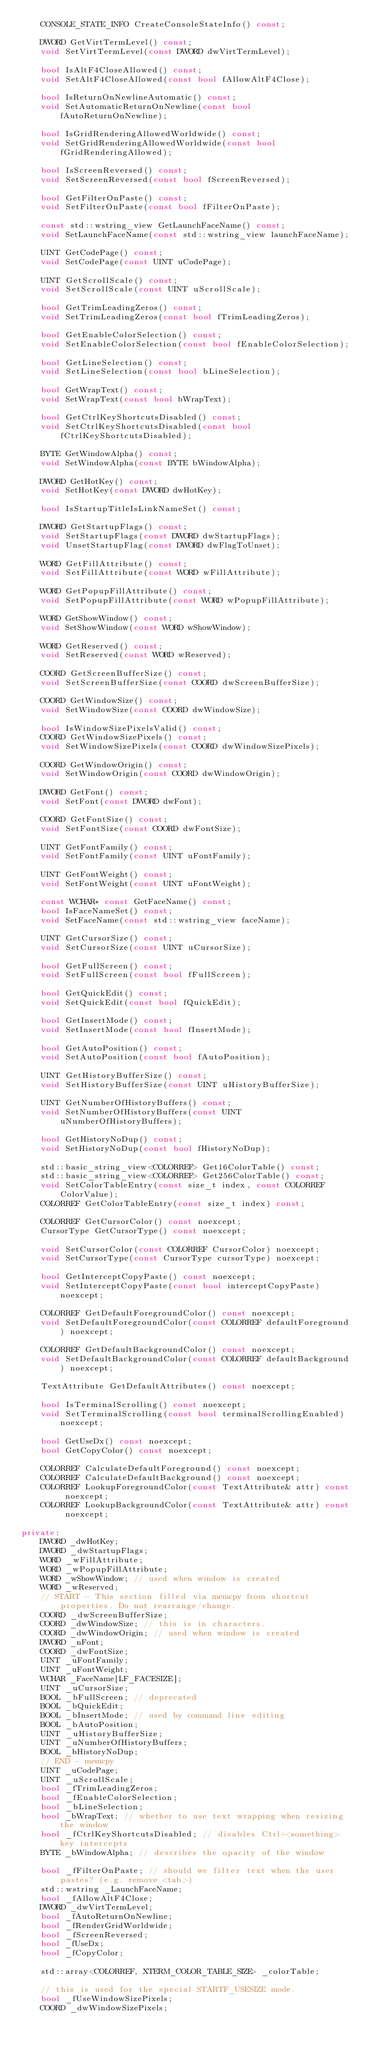<code> <loc_0><loc_0><loc_500><loc_500><_C++_>    CONSOLE_STATE_INFO CreateConsoleStateInfo() const;

    DWORD GetVirtTermLevel() const;
    void SetVirtTermLevel(const DWORD dwVirtTermLevel);

    bool IsAltF4CloseAllowed() const;
    void SetAltF4CloseAllowed(const bool fAllowAltF4Close);

    bool IsReturnOnNewlineAutomatic() const;
    void SetAutomaticReturnOnNewline(const bool fAutoReturnOnNewline);

    bool IsGridRenderingAllowedWorldwide() const;
    void SetGridRenderingAllowedWorldwide(const bool fGridRenderingAllowed);

    bool IsScreenReversed() const;
    void SetScreenReversed(const bool fScreenReversed);

    bool GetFilterOnPaste() const;
    void SetFilterOnPaste(const bool fFilterOnPaste);

    const std::wstring_view GetLaunchFaceName() const;
    void SetLaunchFaceName(const std::wstring_view launchFaceName);

    UINT GetCodePage() const;
    void SetCodePage(const UINT uCodePage);

    UINT GetScrollScale() const;
    void SetScrollScale(const UINT uScrollScale);

    bool GetTrimLeadingZeros() const;
    void SetTrimLeadingZeros(const bool fTrimLeadingZeros);

    bool GetEnableColorSelection() const;
    void SetEnableColorSelection(const bool fEnableColorSelection);

    bool GetLineSelection() const;
    void SetLineSelection(const bool bLineSelection);

    bool GetWrapText() const;
    void SetWrapText(const bool bWrapText);

    bool GetCtrlKeyShortcutsDisabled() const;
    void SetCtrlKeyShortcutsDisabled(const bool fCtrlKeyShortcutsDisabled);

    BYTE GetWindowAlpha() const;
    void SetWindowAlpha(const BYTE bWindowAlpha);

    DWORD GetHotKey() const;
    void SetHotKey(const DWORD dwHotKey);

    bool IsStartupTitleIsLinkNameSet() const;

    DWORD GetStartupFlags() const;
    void SetStartupFlags(const DWORD dwStartupFlags);
    void UnsetStartupFlag(const DWORD dwFlagToUnset);

    WORD GetFillAttribute() const;
    void SetFillAttribute(const WORD wFillAttribute);

    WORD GetPopupFillAttribute() const;
    void SetPopupFillAttribute(const WORD wPopupFillAttribute);

    WORD GetShowWindow() const;
    void SetShowWindow(const WORD wShowWindow);

    WORD GetReserved() const;
    void SetReserved(const WORD wReserved);

    COORD GetScreenBufferSize() const;
    void SetScreenBufferSize(const COORD dwScreenBufferSize);

    COORD GetWindowSize() const;
    void SetWindowSize(const COORD dwWindowSize);

    bool IsWindowSizePixelsValid() const;
    COORD GetWindowSizePixels() const;
    void SetWindowSizePixels(const COORD dwWindowSizePixels);

    COORD GetWindowOrigin() const;
    void SetWindowOrigin(const COORD dwWindowOrigin);

    DWORD GetFont() const;
    void SetFont(const DWORD dwFont);

    COORD GetFontSize() const;
    void SetFontSize(const COORD dwFontSize);

    UINT GetFontFamily() const;
    void SetFontFamily(const UINT uFontFamily);

    UINT GetFontWeight() const;
    void SetFontWeight(const UINT uFontWeight);

    const WCHAR* const GetFaceName() const;
    bool IsFaceNameSet() const;
    void SetFaceName(const std::wstring_view faceName);

    UINT GetCursorSize() const;
    void SetCursorSize(const UINT uCursorSize);

    bool GetFullScreen() const;
    void SetFullScreen(const bool fFullScreen);

    bool GetQuickEdit() const;
    void SetQuickEdit(const bool fQuickEdit);

    bool GetInsertMode() const;
    void SetInsertMode(const bool fInsertMode);

    bool GetAutoPosition() const;
    void SetAutoPosition(const bool fAutoPosition);

    UINT GetHistoryBufferSize() const;
    void SetHistoryBufferSize(const UINT uHistoryBufferSize);

    UINT GetNumberOfHistoryBuffers() const;
    void SetNumberOfHistoryBuffers(const UINT uNumberOfHistoryBuffers);

    bool GetHistoryNoDup() const;
    void SetHistoryNoDup(const bool fHistoryNoDup);

    std::basic_string_view<COLORREF> Get16ColorTable() const;
    std::basic_string_view<COLORREF> Get256ColorTable() const;
    void SetColorTableEntry(const size_t index, const COLORREF ColorValue);
    COLORREF GetColorTableEntry(const size_t index) const;

    COLORREF GetCursorColor() const noexcept;
    CursorType GetCursorType() const noexcept;

    void SetCursorColor(const COLORREF CursorColor) noexcept;
    void SetCursorType(const CursorType cursorType) noexcept;

    bool GetInterceptCopyPaste() const noexcept;
    void SetInterceptCopyPaste(const bool interceptCopyPaste) noexcept;

    COLORREF GetDefaultForegroundColor() const noexcept;
    void SetDefaultForegroundColor(const COLORREF defaultForeground) noexcept;

    COLORREF GetDefaultBackgroundColor() const noexcept;
    void SetDefaultBackgroundColor(const COLORREF defaultBackground) noexcept;

    TextAttribute GetDefaultAttributes() const noexcept;

    bool IsTerminalScrolling() const noexcept;
    void SetTerminalScrolling(const bool terminalScrollingEnabled) noexcept;

    bool GetUseDx() const noexcept;
    bool GetCopyColor() const noexcept;

    COLORREF CalculateDefaultForeground() const noexcept;
    COLORREF CalculateDefaultBackground() const noexcept;
    COLORREF LookupForegroundColor(const TextAttribute& attr) const noexcept;
    COLORREF LookupBackgroundColor(const TextAttribute& attr) const noexcept;

private:
    DWORD _dwHotKey;
    DWORD _dwStartupFlags;
    WORD _wFillAttribute;
    WORD _wPopupFillAttribute;
    WORD _wShowWindow; // used when window is created
    WORD _wReserved;
    // START - This section filled via memcpy from shortcut properties. Do not rearrange/change.
    COORD _dwScreenBufferSize;
    COORD _dwWindowSize; // this is in characters.
    COORD _dwWindowOrigin; // used when window is created
    DWORD _nFont;
    COORD _dwFontSize;
    UINT _uFontFamily;
    UINT _uFontWeight;
    WCHAR _FaceName[LF_FACESIZE];
    UINT _uCursorSize;
    BOOL _bFullScreen; // deprecated
    BOOL _bQuickEdit;
    BOOL _bInsertMode; // used by command line editing
    BOOL _bAutoPosition;
    UINT _uHistoryBufferSize;
    UINT _uNumberOfHistoryBuffers;
    BOOL _bHistoryNoDup;
    // END - memcpy
    UINT _uCodePage;
    UINT _uScrollScale;
    bool _fTrimLeadingZeros;
    bool _fEnableColorSelection;
    bool _bLineSelection;
    bool _bWrapText; // whether to use text wrapping when resizing the window
    bool _fCtrlKeyShortcutsDisabled; // disables Ctrl+<something> key intercepts
    BYTE _bWindowAlpha; // describes the opacity of the window

    bool _fFilterOnPaste; // should we filter text when the user pastes? (e.g. remove <tab>)
    std::wstring _LaunchFaceName;
    bool _fAllowAltF4Close;
    DWORD _dwVirtTermLevel;
    bool _fAutoReturnOnNewline;
    bool _fRenderGridWorldwide;
    bool _fScreenReversed;
    bool _fUseDx;
    bool _fCopyColor;

    std::array<COLORREF, XTERM_COLOR_TABLE_SIZE> _colorTable;

    // this is used for the special STARTF_USESIZE mode.
    bool _fUseWindowSizePixels;
    COORD _dwWindowSizePixels;</code> 